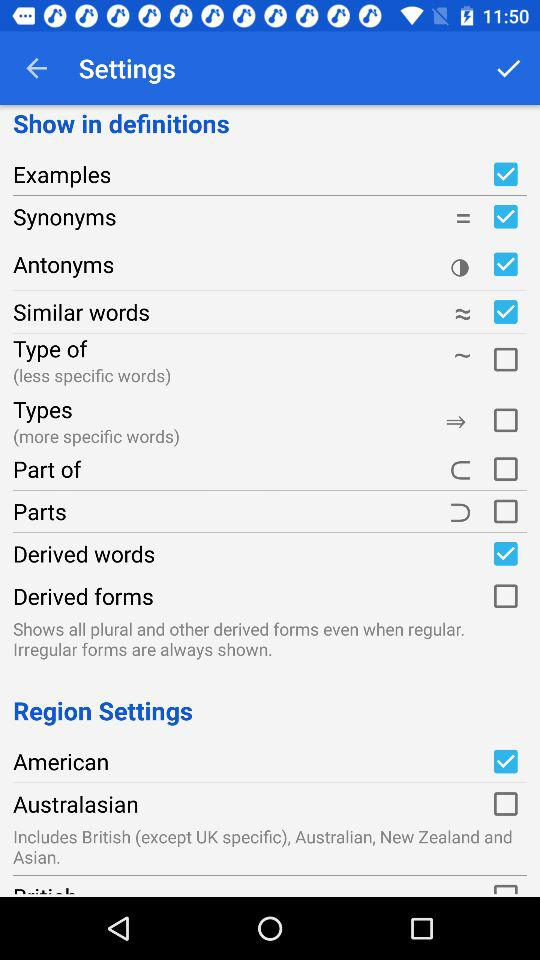What is the current status of "Derived words"? The current status of "Derived words" is "on". 